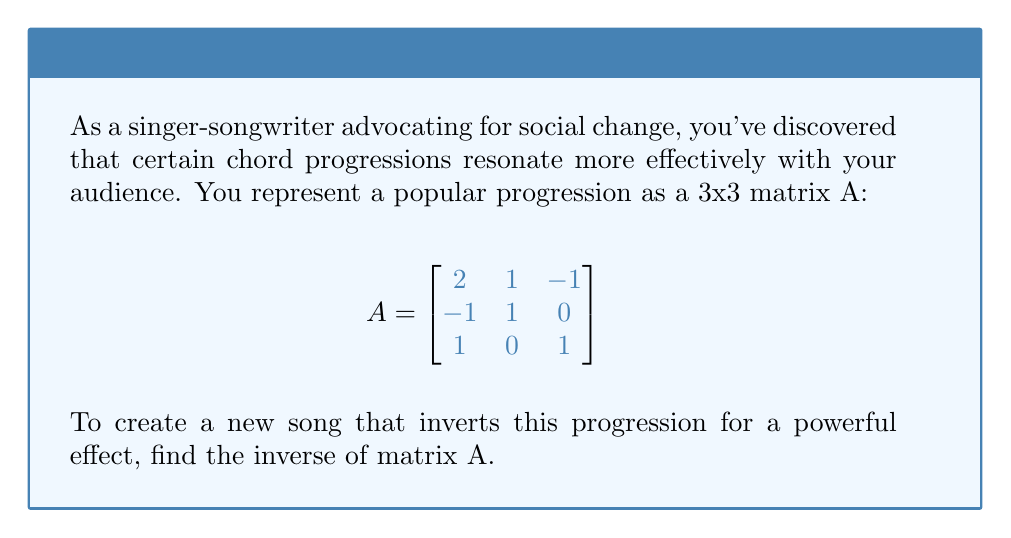Can you solve this math problem? To find the inverse of matrix A, we'll follow these steps:

1) First, calculate the determinant of A:
   $det(A) = 2(1) - 1(-1) + (-1)(1) = 2 + 1 - 1 = 2$
   Since $det(A) \neq 0$, A is invertible.

2) Find the adjugate matrix (adj(A)):
   a) Calculate the cofactor matrix:
      $C_{11} = 1(1) - 0(0) = 1$
      $C_{12} = -(-1(1) - 0(1)) = 1$
      $C_{13} = -(-1(0) - 1(1)) = 1$
      $C_{21} = -(1(1) - (-1)(1)) = -2$
      $C_{22} = 2(1) - (-1)(1) = 3$
      $C_{23} = -(2(0) - (-1)(-1)) = -1$
      $C_{31} = -(1(-1) - 0(1)) = 1$
      $C_{32} = -(2(-1) - 1(1)) = 3$
      $C_{33} = 2(1) - 1(1) = 1$

   b) Transpose the cofactor matrix to get adj(A):
      $$ adj(A) = \begin{bmatrix}
      1 & 1 & 1 \\
      -2 & 3 & 3 \\
      1 & -1 & 1
      \end{bmatrix} $$

3) Calculate $A^{-1}$ using the formula: $A^{-1} = \frac{1}{det(A)} adj(A)$

   $$ A^{-1} = \frac{1}{2} \begin{bmatrix}
   1 & 1 & 1 \\
   -2 & 3 & 3 \\
   1 & -1 & 1
   \end{bmatrix} $$

4) Simplify:
   $$ A^{-1} = \begin{bmatrix}
   1/2 & 1/2 & 1/2 \\
   -1 & 3/2 & 3/2 \\
   1/2 & -1/2 & 1/2
   \end{bmatrix} $$
Answer: $$ A^{-1} = \begin{bmatrix}
1/2 & 1/2 & 1/2 \\
-1 & 3/2 & 3/2 \\
1/2 & -1/2 & 1/2
\end{bmatrix} $$ 